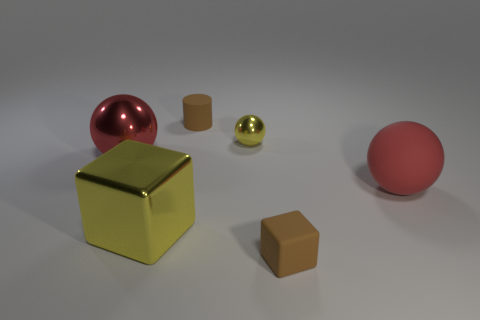Is the number of matte spheres that are left of the big yellow shiny cube greater than the number of yellow rubber balls?
Ensure brevity in your answer.  No. Is there any other thing of the same color as the small cylinder?
Your answer should be compact. Yes. What shape is the yellow object behind the big thing that is to the left of the big yellow block?
Offer a terse response. Sphere. Are there more shiny objects than yellow balls?
Your answer should be compact. Yes. How many large objects are both to the right of the big shiny sphere and on the left side of the red rubber sphere?
Keep it short and to the point. 1. There is a brown rubber object in front of the shiny cube; what number of tiny objects are to the right of it?
Your answer should be compact. 0. What number of things are objects that are to the right of the tiny shiny object or tiny things that are behind the yellow metal sphere?
Offer a very short reply. 3. There is a small object that is the same shape as the large yellow object; what is its material?
Offer a terse response. Rubber. How many objects are spheres on the left side of the metal cube or brown matte cylinders?
Provide a short and direct response. 2. What shape is the big red object that is the same material as the tiny cube?
Your answer should be very brief. Sphere. 